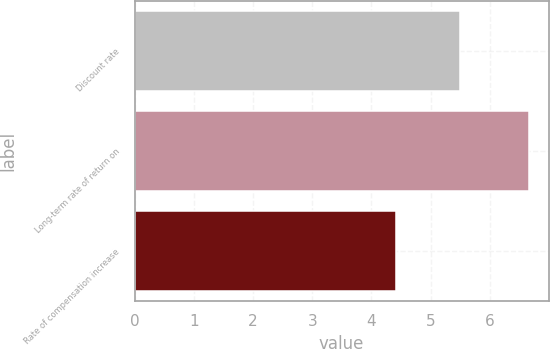Convert chart to OTSL. <chart><loc_0><loc_0><loc_500><loc_500><bar_chart><fcel>Discount rate<fcel>Long-term rate of return on<fcel>Rate of compensation increase<nl><fcel>5.5<fcel>6.66<fcel>4.42<nl></chart> 